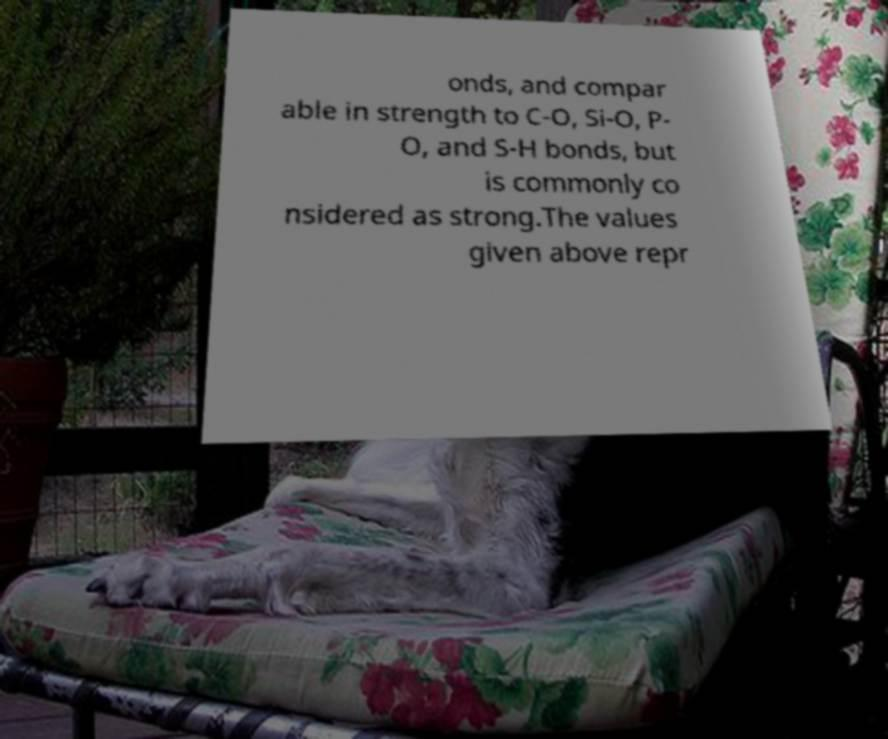Please read and relay the text visible in this image. What does it say? onds, and compar able in strength to C-O, Si-O, P- O, and S-H bonds, but is commonly co nsidered as strong.The values given above repr 